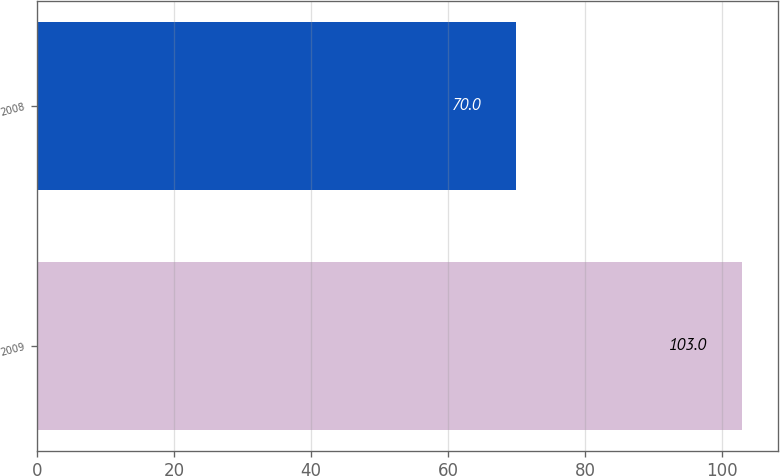Convert chart to OTSL. <chart><loc_0><loc_0><loc_500><loc_500><bar_chart><fcel>2009<fcel>2008<nl><fcel>103<fcel>70<nl></chart> 